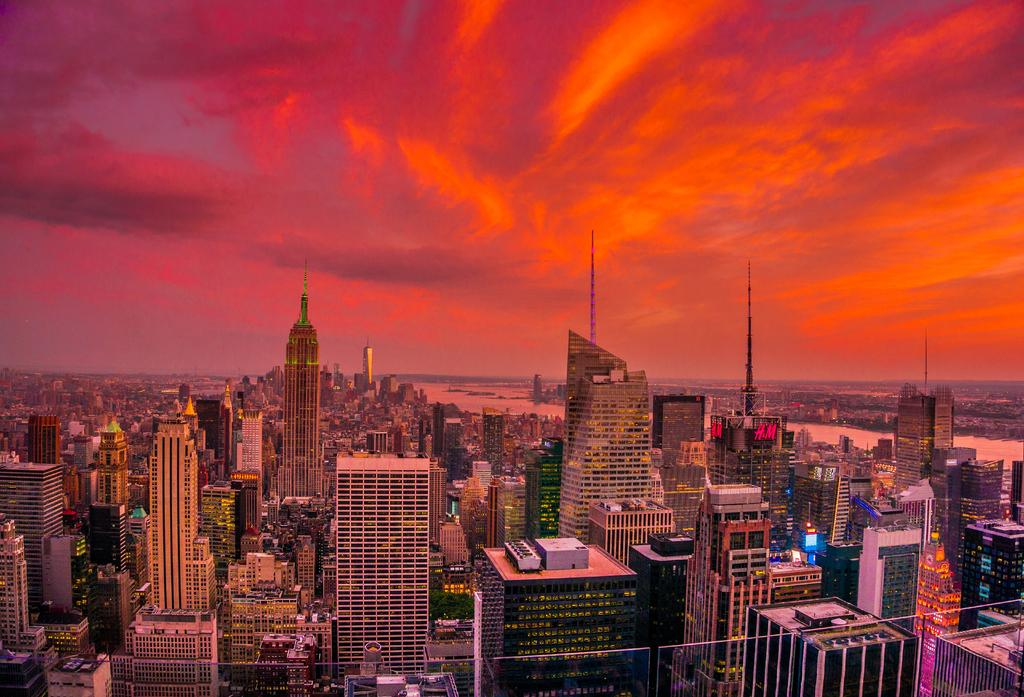What type of structures can be seen in the image? There are many buildings and skyscrapers in the image. What natural element is visible in the background of the image? There is water visible in the background of the image. What is visible at the top of the image? The sky is visible at the top of the image. What type of fruit can be seen floating in the water in the image? There is no fruit visible in the image, and the water is not mentioned to contain any objects. 